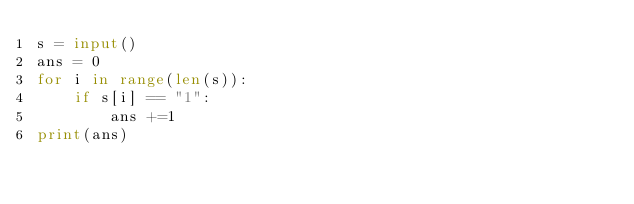<code> <loc_0><loc_0><loc_500><loc_500><_Python_>s = input()
ans = 0
for i in range(len(s)):
    if s[i] == "1":
        ans +=1
print(ans)</code> 